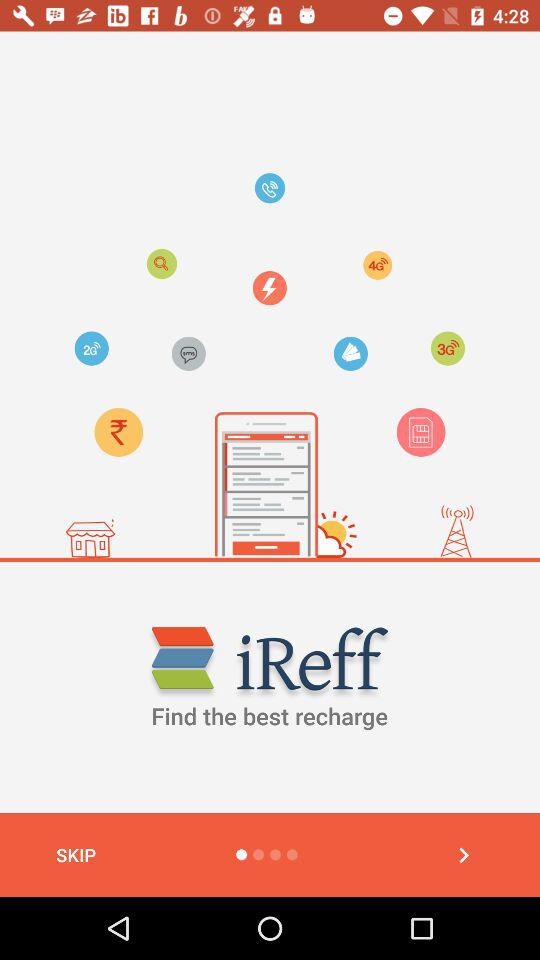What is the name of the application? The name of the application is "iReff". 